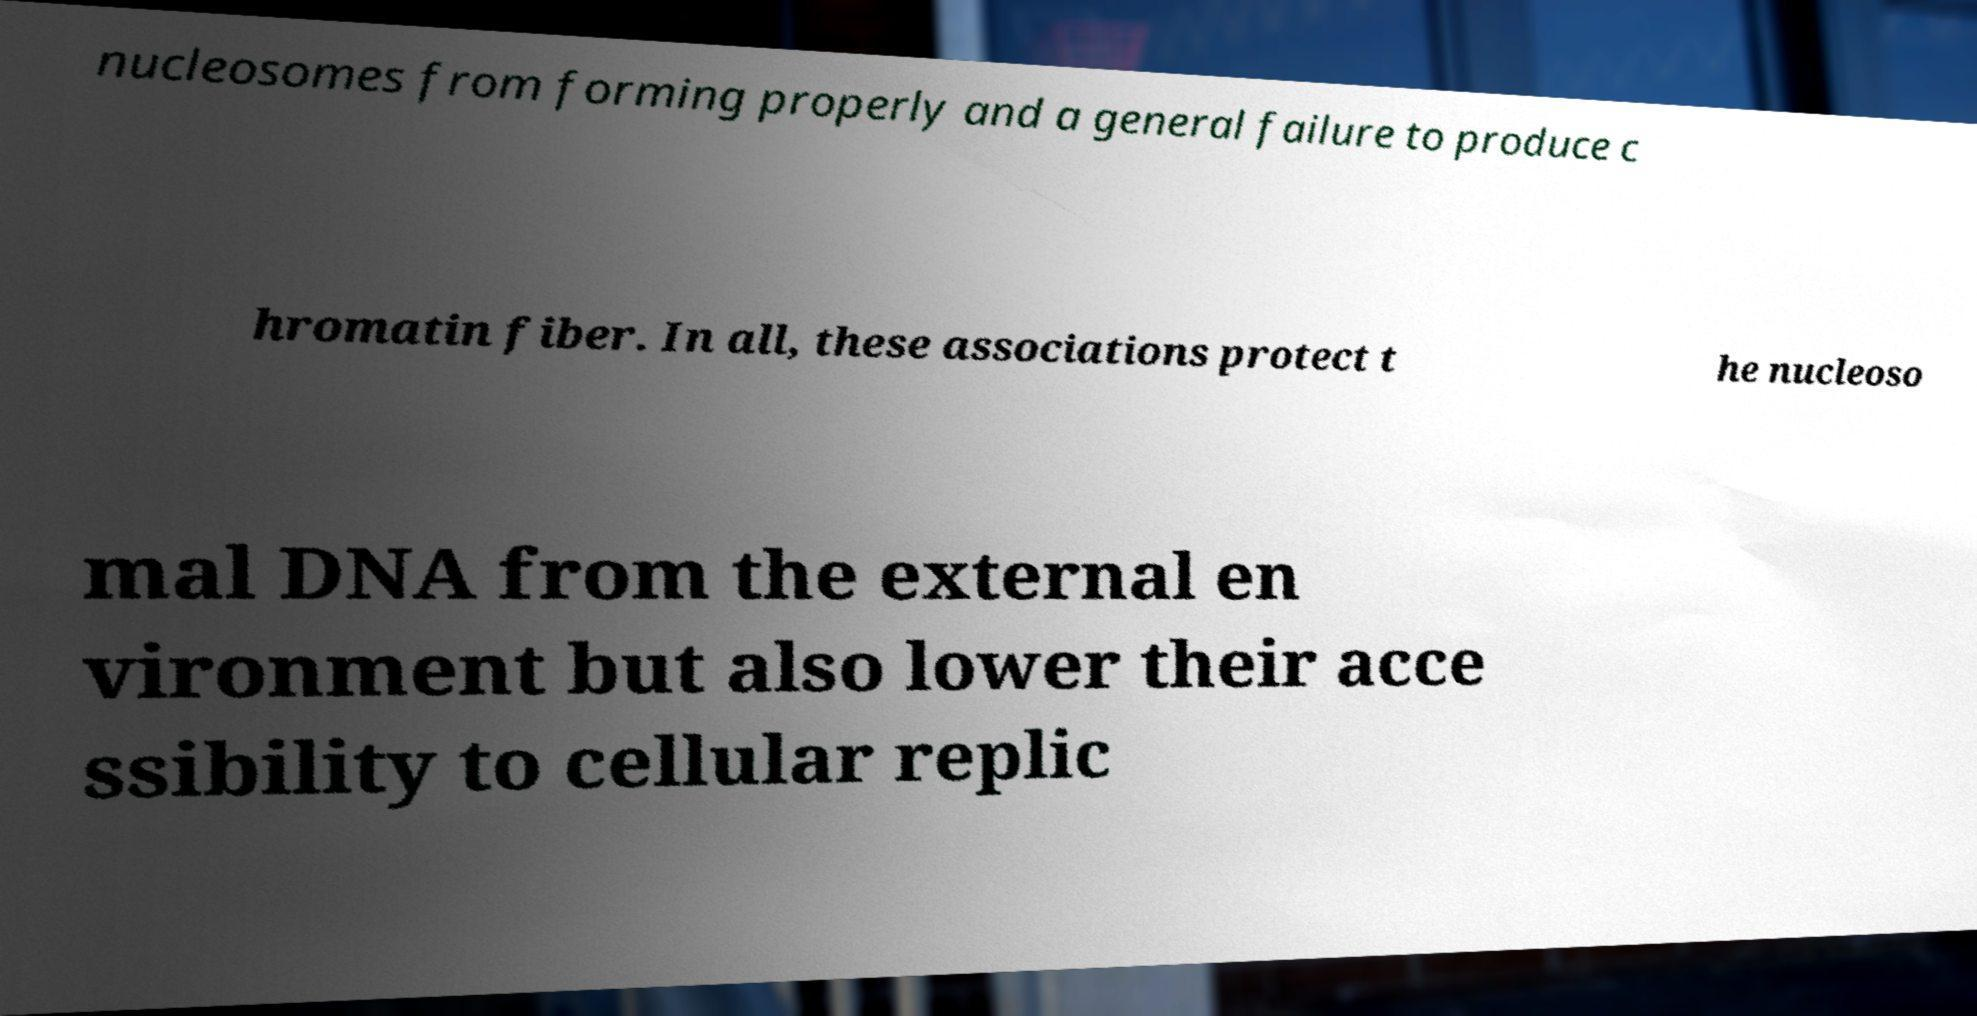Please read and relay the text visible in this image. What does it say? nucleosomes from forming properly and a general failure to produce c hromatin fiber. In all, these associations protect t he nucleoso mal DNA from the external en vironment but also lower their acce ssibility to cellular replic 